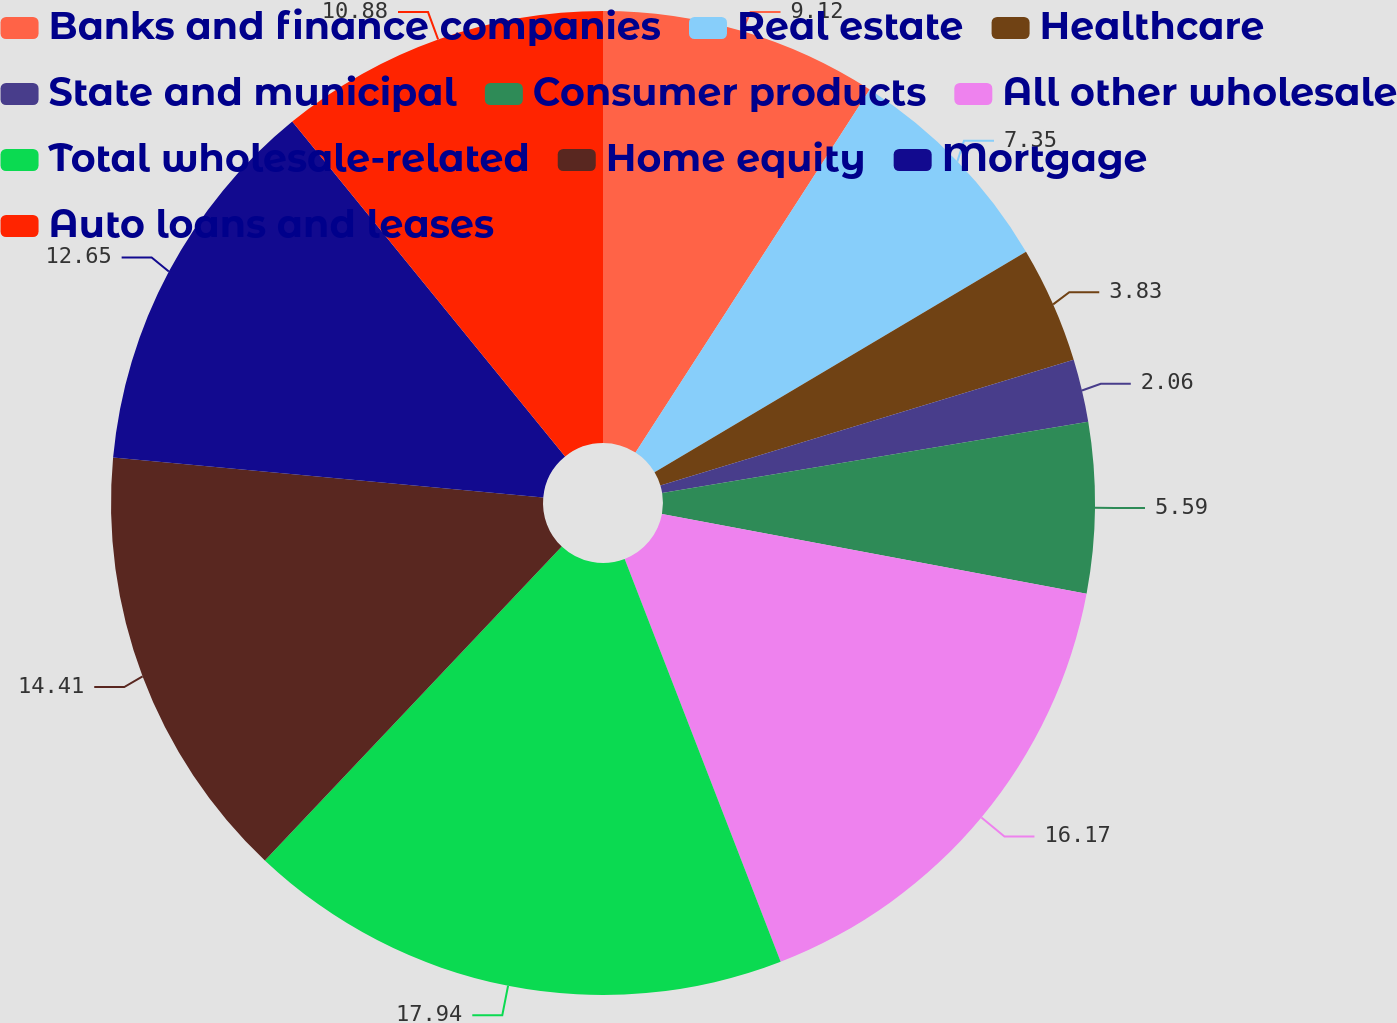Convert chart. <chart><loc_0><loc_0><loc_500><loc_500><pie_chart><fcel>Banks and finance companies<fcel>Real estate<fcel>Healthcare<fcel>State and municipal<fcel>Consumer products<fcel>All other wholesale<fcel>Total wholesale-related<fcel>Home equity<fcel>Mortgage<fcel>Auto loans and leases<nl><fcel>9.12%<fcel>7.35%<fcel>3.83%<fcel>2.06%<fcel>5.59%<fcel>16.17%<fcel>17.94%<fcel>14.41%<fcel>12.65%<fcel>10.88%<nl></chart> 